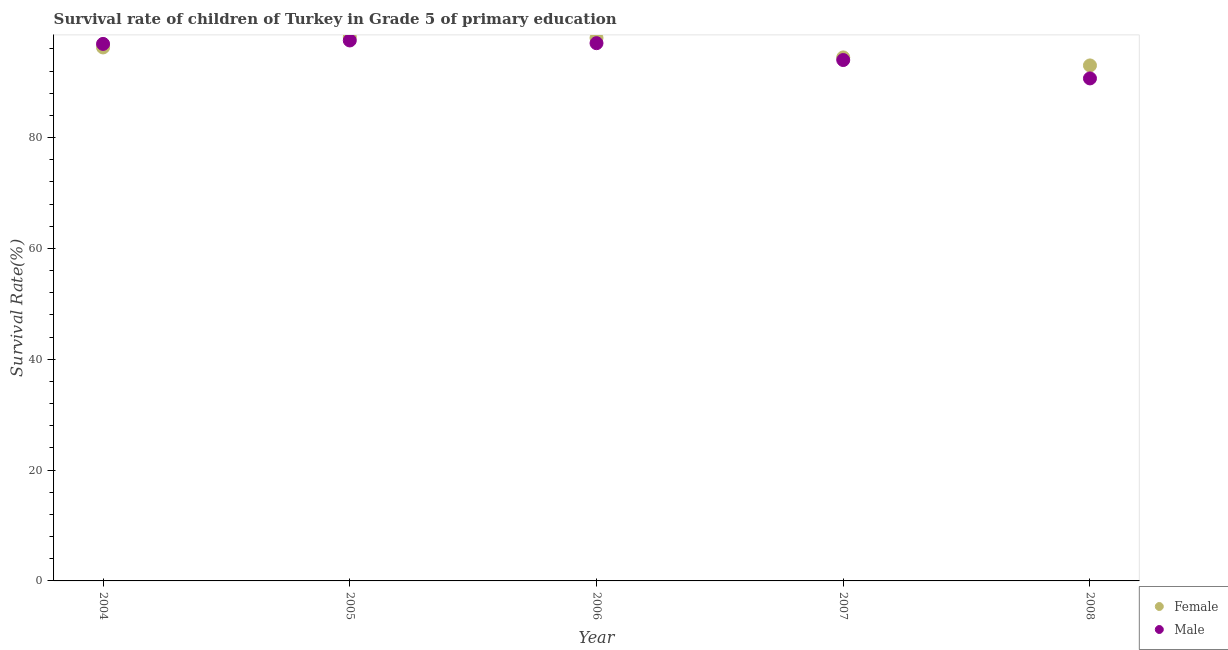What is the survival rate of male students in primary education in 2008?
Give a very brief answer. 90.68. Across all years, what is the maximum survival rate of female students in primary education?
Your response must be concise. 98.17. Across all years, what is the minimum survival rate of male students in primary education?
Keep it short and to the point. 90.68. What is the total survival rate of female students in primary education in the graph?
Your response must be concise. 479.93. What is the difference between the survival rate of female students in primary education in 2004 and that in 2007?
Keep it short and to the point. 1.8. What is the difference between the survival rate of female students in primary education in 2007 and the survival rate of male students in primary education in 2004?
Make the answer very short. -2.44. What is the average survival rate of male students in primary education per year?
Provide a short and direct response. 95.24. In the year 2007, what is the difference between the survival rate of female students in primary education and survival rate of male students in primary education?
Your response must be concise. 0.47. In how many years, is the survival rate of male students in primary education greater than 60 %?
Keep it short and to the point. 5. What is the ratio of the survival rate of male students in primary education in 2004 to that in 2006?
Your response must be concise. 1. Is the difference between the survival rate of female students in primary education in 2005 and 2007 greater than the difference between the survival rate of male students in primary education in 2005 and 2007?
Make the answer very short. Yes. What is the difference between the highest and the second highest survival rate of male students in primary education?
Make the answer very short. 0.49. What is the difference between the highest and the lowest survival rate of female students in primary education?
Provide a short and direct response. 5.14. In how many years, is the survival rate of male students in primary education greater than the average survival rate of male students in primary education taken over all years?
Your answer should be compact. 3. Is the sum of the survival rate of female students in primary education in 2004 and 2008 greater than the maximum survival rate of male students in primary education across all years?
Offer a very short reply. Yes. Is the survival rate of male students in primary education strictly greater than the survival rate of female students in primary education over the years?
Keep it short and to the point. No. Is the survival rate of female students in primary education strictly less than the survival rate of male students in primary education over the years?
Ensure brevity in your answer.  No. How many dotlines are there?
Make the answer very short. 2. What is the difference between two consecutive major ticks on the Y-axis?
Offer a terse response. 20. Are the values on the major ticks of Y-axis written in scientific E-notation?
Offer a terse response. No. Does the graph contain any zero values?
Keep it short and to the point. No. Does the graph contain grids?
Offer a terse response. No. Where does the legend appear in the graph?
Offer a very short reply. Bottom right. How many legend labels are there?
Your response must be concise. 2. What is the title of the graph?
Provide a succinct answer. Survival rate of children of Turkey in Grade 5 of primary education. Does "Arms exports" appear as one of the legend labels in the graph?
Offer a terse response. No. What is the label or title of the X-axis?
Provide a succinct answer. Year. What is the label or title of the Y-axis?
Your response must be concise. Survival Rate(%). What is the Survival Rate(%) in Female in 2004?
Your response must be concise. 96.27. What is the Survival Rate(%) of Male in 2004?
Provide a succinct answer. 96.91. What is the Survival Rate(%) in Female in 2005?
Your response must be concise. 98.17. What is the Survival Rate(%) in Male in 2005?
Offer a very short reply. 97.53. What is the Survival Rate(%) in Female in 2006?
Make the answer very short. 97.99. What is the Survival Rate(%) in Male in 2006?
Provide a short and direct response. 97.04. What is the Survival Rate(%) of Female in 2007?
Keep it short and to the point. 94.47. What is the Survival Rate(%) in Male in 2007?
Your answer should be very brief. 94. What is the Survival Rate(%) of Female in 2008?
Your response must be concise. 93.03. What is the Survival Rate(%) of Male in 2008?
Keep it short and to the point. 90.68. Across all years, what is the maximum Survival Rate(%) of Female?
Make the answer very short. 98.17. Across all years, what is the maximum Survival Rate(%) of Male?
Ensure brevity in your answer.  97.53. Across all years, what is the minimum Survival Rate(%) in Female?
Keep it short and to the point. 93.03. Across all years, what is the minimum Survival Rate(%) of Male?
Give a very brief answer. 90.68. What is the total Survival Rate(%) of Female in the graph?
Provide a short and direct response. 479.93. What is the total Survival Rate(%) in Male in the graph?
Provide a short and direct response. 476.18. What is the difference between the Survival Rate(%) of Female in 2004 and that in 2005?
Offer a very short reply. -1.89. What is the difference between the Survival Rate(%) of Male in 2004 and that in 2005?
Offer a terse response. -0.62. What is the difference between the Survival Rate(%) of Female in 2004 and that in 2006?
Provide a short and direct response. -1.72. What is the difference between the Survival Rate(%) in Male in 2004 and that in 2006?
Provide a succinct answer. -0.13. What is the difference between the Survival Rate(%) of Female in 2004 and that in 2007?
Your answer should be very brief. 1.8. What is the difference between the Survival Rate(%) in Male in 2004 and that in 2007?
Keep it short and to the point. 2.91. What is the difference between the Survival Rate(%) in Female in 2004 and that in 2008?
Your answer should be compact. 3.25. What is the difference between the Survival Rate(%) in Male in 2004 and that in 2008?
Provide a succinct answer. 6.23. What is the difference between the Survival Rate(%) of Female in 2005 and that in 2006?
Offer a very short reply. 0.18. What is the difference between the Survival Rate(%) of Male in 2005 and that in 2006?
Keep it short and to the point. 0.49. What is the difference between the Survival Rate(%) of Female in 2005 and that in 2007?
Your answer should be very brief. 3.69. What is the difference between the Survival Rate(%) of Male in 2005 and that in 2007?
Give a very brief answer. 3.53. What is the difference between the Survival Rate(%) of Female in 2005 and that in 2008?
Your answer should be very brief. 5.14. What is the difference between the Survival Rate(%) of Male in 2005 and that in 2008?
Provide a short and direct response. 6.85. What is the difference between the Survival Rate(%) of Female in 2006 and that in 2007?
Provide a succinct answer. 3.52. What is the difference between the Survival Rate(%) of Male in 2006 and that in 2007?
Make the answer very short. 3.04. What is the difference between the Survival Rate(%) of Female in 2006 and that in 2008?
Offer a very short reply. 4.96. What is the difference between the Survival Rate(%) in Male in 2006 and that in 2008?
Your response must be concise. 6.36. What is the difference between the Survival Rate(%) in Female in 2007 and that in 2008?
Make the answer very short. 1.45. What is the difference between the Survival Rate(%) of Male in 2007 and that in 2008?
Your answer should be very brief. 3.32. What is the difference between the Survival Rate(%) of Female in 2004 and the Survival Rate(%) of Male in 2005?
Your response must be concise. -1.26. What is the difference between the Survival Rate(%) of Female in 2004 and the Survival Rate(%) of Male in 2006?
Your response must be concise. -0.77. What is the difference between the Survival Rate(%) in Female in 2004 and the Survival Rate(%) in Male in 2007?
Your answer should be very brief. 2.27. What is the difference between the Survival Rate(%) in Female in 2004 and the Survival Rate(%) in Male in 2008?
Provide a succinct answer. 5.59. What is the difference between the Survival Rate(%) of Female in 2005 and the Survival Rate(%) of Male in 2006?
Keep it short and to the point. 1.12. What is the difference between the Survival Rate(%) of Female in 2005 and the Survival Rate(%) of Male in 2007?
Provide a short and direct response. 4.17. What is the difference between the Survival Rate(%) in Female in 2005 and the Survival Rate(%) in Male in 2008?
Give a very brief answer. 7.48. What is the difference between the Survival Rate(%) of Female in 2006 and the Survival Rate(%) of Male in 2007?
Give a very brief answer. 3.99. What is the difference between the Survival Rate(%) in Female in 2006 and the Survival Rate(%) in Male in 2008?
Make the answer very short. 7.31. What is the difference between the Survival Rate(%) in Female in 2007 and the Survival Rate(%) in Male in 2008?
Keep it short and to the point. 3.79. What is the average Survival Rate(%) in Female per year?
Offer a very short reply. 95.99. What is the average Survival Rate(%) in Male per year?
Provide a short and direct response. 95.24. In the year 2004, what is the difference between the Survival Rate(%) of Female and Survival Rate(%) of Male?
Your answer should be compact. -0.64. In the year 2005, what is the difference between the Survival Rate(%) in Female and Survival Rate(%) in Male?
Your response must be concise. 0.64. In the year 2006, what is the difference between the Survival Rate(%) of Female and Survival Rate(%) of Male?
Provide a short and direct response. 0.95. In the year 2007, what is the difference between the Survival Rate(%) of Female and Survival Rate(%) of Male?
Offer a very short reply. 0.47. In the year 2008, what is the difference between the Survival Rate(%) of Female and Survival Rate(%) of Male?
Your response must be concise. 2.34. What is the ratio of the Survival Rate(%) of Female in 2004 to that in 2005?
Provide a short and direct response. 0.98. What is the ratio of the Survival Rate(%) of Female in 2004 to that in 2006?
Your answer should be very brief. 0.98. What is the ratio of the Survival Rate(%) in Male in 2004 to that in 2006?
Your response must be concise. 1. What is the ratio of the Survival Rate(%) of Female in 2004 to that in 2007?
Ensure brevity in your answer.  1.02. What is the ratio of the Survival Rate(%) in Male in 2004 to that in 2007?
Your answer should be compact. 1.03. What is the ratio of the Survival Rate(%) of Female in 2004 to that in 2008?
Offer a very short reply. 1.03. What is the ratio of the Survival Rate(%) in Male in 2004 to that in 2008?
Keep it short and to the point. 1.07. What is the ratio of the Survival Rate(%) of Female in 2005 to that in 2006?
Your answer should be very brief. 1. What is the ratio of the Survival Rate(%) in Male in 2005 to that in 2006?
Provide a short and direct response. 1. What is the ratio of the Survival Rate(%) in Female in 2005 to that in 2007?
Offer a terse response. 1.04. What is the ratio of the Survival Rate(%) of Male in 2005 to that in 2007?
Keep it short and to the point. 1.04. What is the ratio of the Survival Rate(%) in Female in 2005 to that in 2008?
Offer a very short reply. 1.06. What is the ratio of the Survival Rate(%) of Male in 2005 to that in 2008?
Give a very brief answer. 1.08. What is the ratio of the Survival Rate(%) in Female in 2006 to that in 2007?
Provide a short and direct response. 1.04. What is the ratio of the Survival Rate(%) of Male in 2006 to that in 2007?
Keep it short and to the point. 1.03. What is the ratio of the Survival Rate(%) of Female in 2006 to that in 2008?
Your response must be concise. 1.05. What is the ratio of the Survival Rate(%) of Male in 2006 to that in 2008?
Keep it short and to the point. 1.07. What is the ratio of the Survival Rate(%) of Female in 2007 to that in 2008?
Give a very brief answer. 1.02. What is the ratio of the Survival Rate(%) in Male in 2007 to that in 2008?
Your answer should be compact. 1.04. What is the difference between the highest and the second highest Survival Rate(%) in Female?
Ensure brevity in your answer.  0.18. What is the difference between the highest and the second highest Survival Rate(%) of Male?
Give a very brief answer. 0.49. What is the difference between the highest and the lowest Survival Rate(%) in Female?
Your response must be concise. 5.14. What is the difference between the highest and the lowest Survival Rate(%) of Male?
Offer a very short reply. 6.85. 